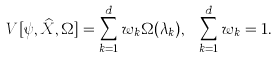Convert formula to latex. <formula><loc_0><loc_0><loc_500><loc_500>V [ \psi , \widehat { X } , \Omega ] = \sum _ { k = 1 } ^ { d } w _ { k } \Omega ( \lambda _ { k } ) , \text { } \sum _ { k = 1 } ^ { d } w _ { k } = 1 .</formula> 